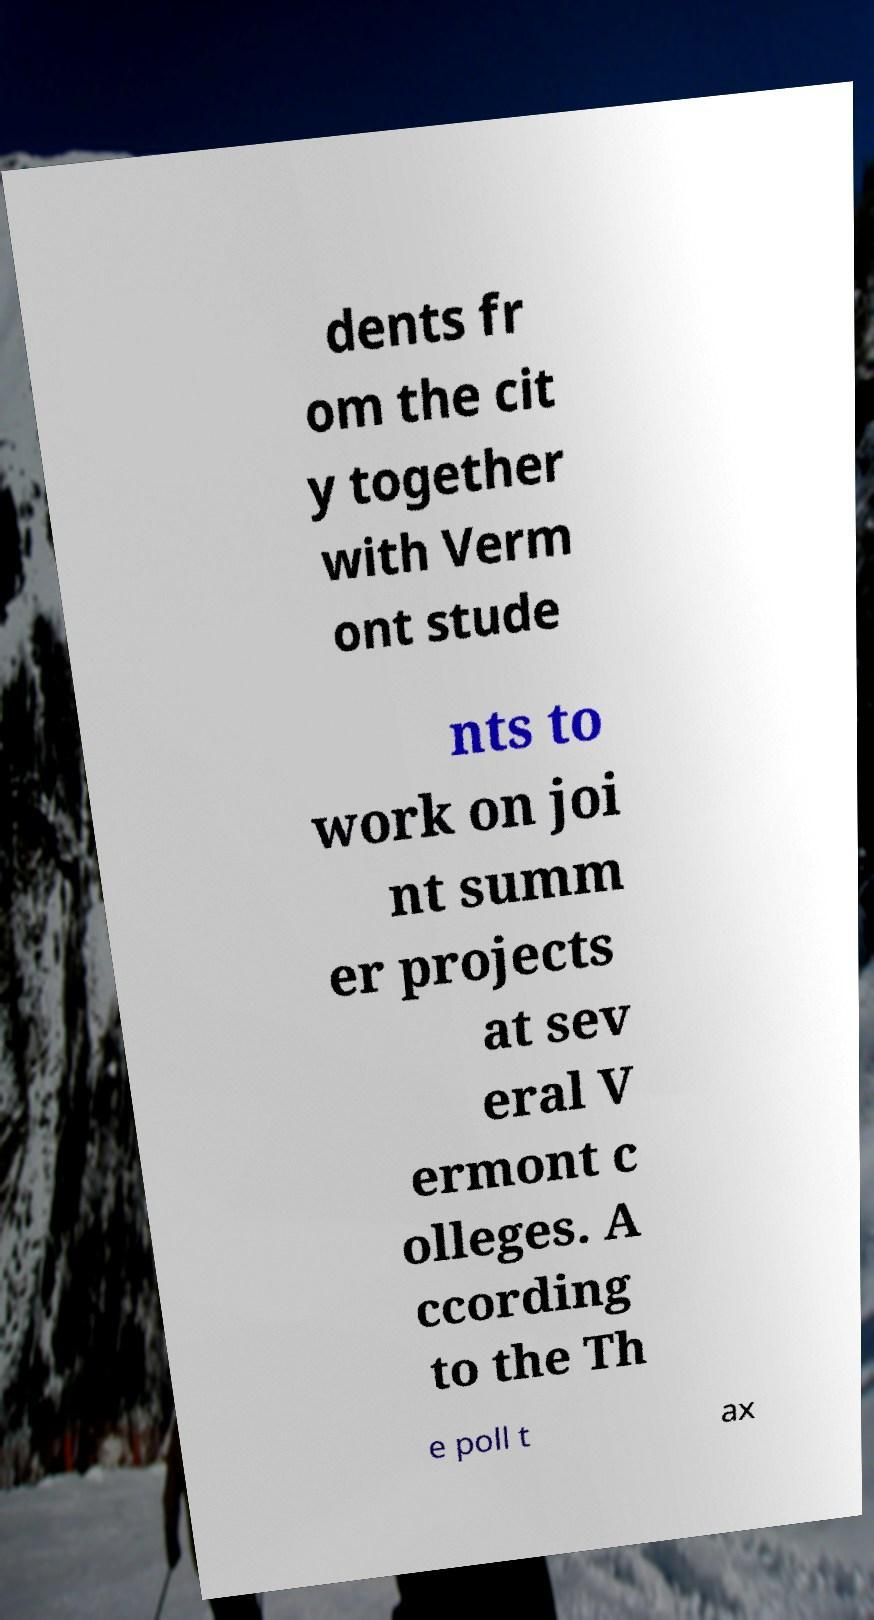Could you assist in decoding the text presented in this image and type it out clearly? dents fr om the cit y together with Verm ont stude nts to work on joi nt summ er projects at sev eral V ermont c olleges. A ccording to the Th e poll t ax 